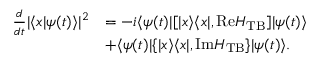<formula> <loc_0><loc_0><loc_500><loc_500>\begin{array} { r l } { \frac { d } { d t } | \langle x | \psi ( t ) \rangle | ^ { 2 } } & { = - i \langle \psi ( t ) | [ | x \rangle \langle x | , R e H _ { T B } ] | \psi ( t ) \rangle } \\ & { + \langle \psi ( t ) | \{ | x \rangle \langle x | , I m H _ { T B } \} | \psi ( t ) \rangle . } \end{array}</formula> 